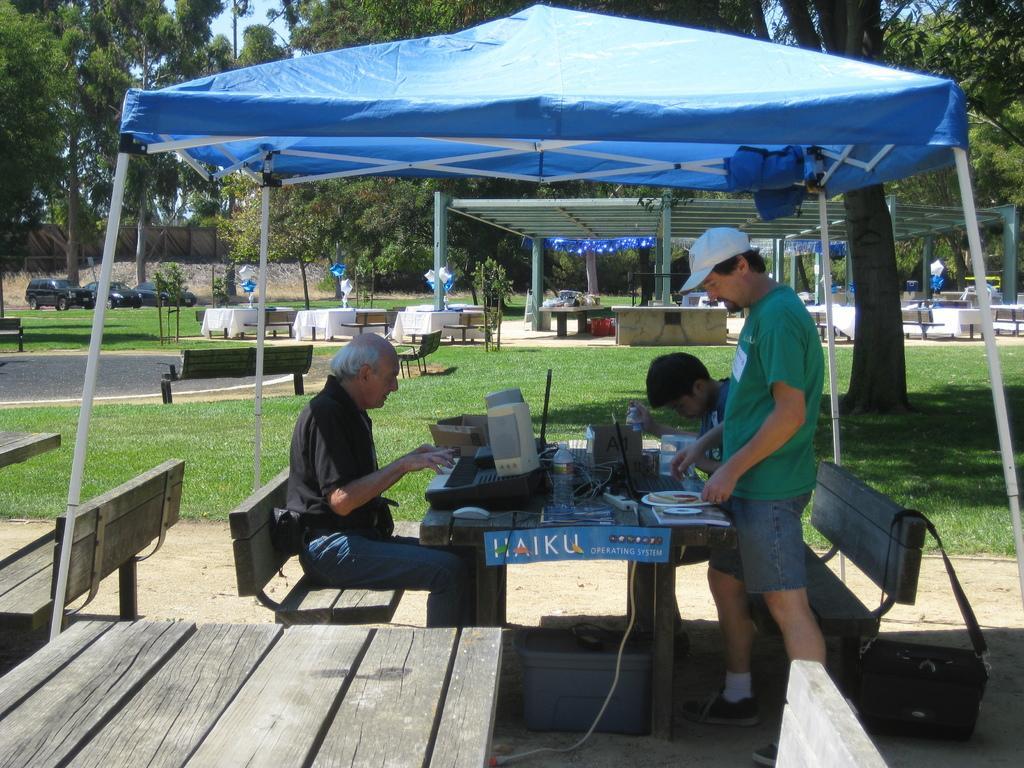Please provide a concise description of this image. This is a picture of a man standing and group of people sitting in the chair near the table and in back ground there is car , tree , tent , benches. 